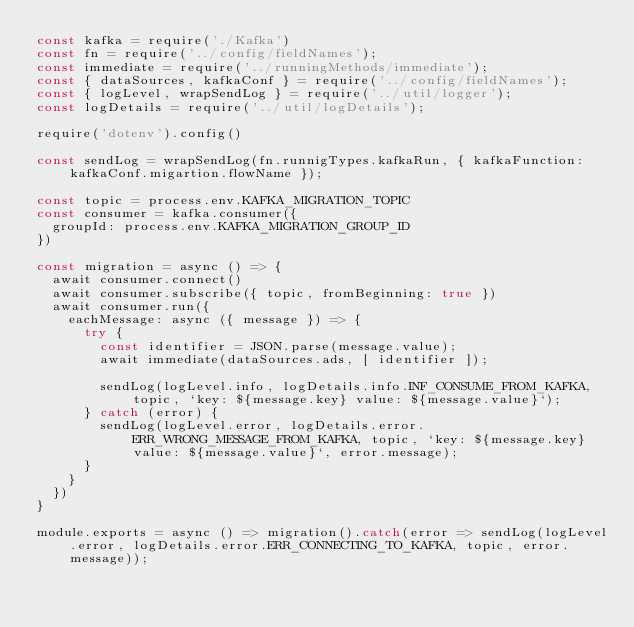<code> <loc_0><loc_0><loc_500><loc_500><_JavaScript_>const kafka = require('./Kafka')
const fn = require('../config/fieldNames');
const immediate = require('../runningMethods/immediate');
const { dataSources, kafkaConf } = require('../config/fieldNames');
const { logLevel, wrapSendLog } = require('../util/logger');
const logDetails = require('../util/logDetails');

require('dotenv').config()

const sendLog = wrapSendLog(fn.runnigTypes.kafkaRun, { kafkaFunction: kafkaConf.migartion.flowName });

const topic = process.env.KAFKA_MIGRATION_TOPIC
const consumer = kafka.consumer({
  groupId: process.env.KAFKA_MIGRATION_GROUP_ID
})

const migration = async () => {
  await consumer.connect()
  await consumer.subscribe({ topic, fromBeginning: true })
  await consumer.run({
    eachMessage: async ({ message }) => {
      try {
        const identifier = JSON.parse(message.value);
        await immediate(dataSources.ads, [ identifier ]);

        sendLog(logLevel.info, logDetails.info.INF_CONSUME_FROM_KAFKA, topic, `key: ${message.key} value: ${message.value}`);
      } catch (error) {
        sendLog(logLevel.error, logDetails.error.ERR_WRONG_MESSAGE_FROM_KAFKA, topic, `key: ${message.key} value: ${message.value}`, error.message);
      }
    }
  })
}

module.exports = async () => migration().catch(error => sendLog(logLevel.error, logDetails.error.ERR_CONNECTING_TO_KAFKA, topic, error.message));
</code> 